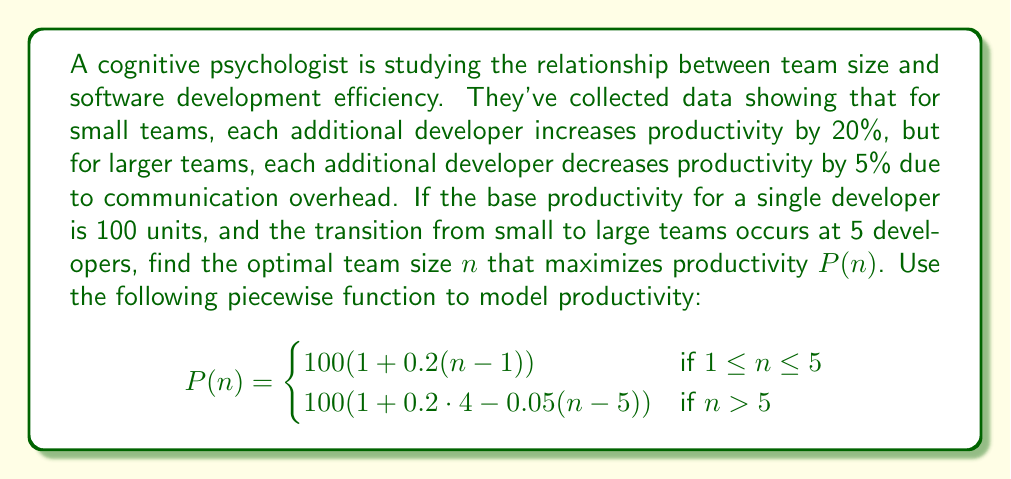Can you solve this math problem? To find the optimal team size, we need to analyze both pieces of the function:

1. For $1 \leq n \leq 5$:
   $P(n) = 100(1 + 0.2(n-1)) = 100 + 20n - 20 = 20n + 80$
   This is increasing linearly, so the maximum in this range occurs at $n = 5$.

2. For $n > 5$:
   $P(n) = 100(1 + 0.2 \cdot 4 - 0.05(n-5)) = 100(1.8 - 0.05n + 0.25) = 100(2.05 - 0.05n)$
   $P(n) = 205 - 5n$

To find the maximum of the second piece:
   Set the derivative to zero: $\frac{d}{dn}P(n) = -5 = 0$
   This is always negative, so $P(n)$ is decreasing for $n > 5$.

Therefore, the maximum productivity occurs at the transition point, $n = 5$.

To verify, calculate $P(5)$ and $P(6)$:
   $P(5) = 20(5) + 80 = 180$
   $P(6) = 205 - 5(6) = 175$

Indeed, $P(5) > P(6)$, confirming that productivity decreases after 5 developers.
Answer: The optimal team size to maximize software development efficiency is 5 developers. 